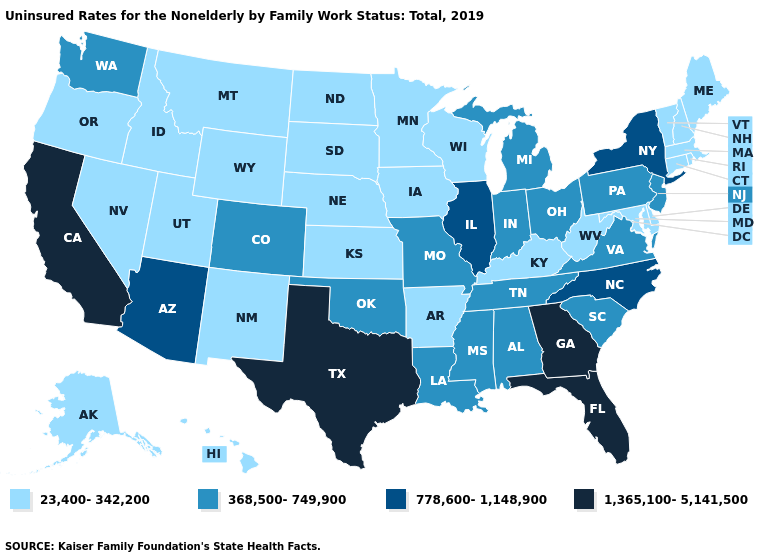What is the value of Alabama?
Short answer required. 368,500-749,900. What is the value of South Carolina?
Quick response, please. 368,500-749,900. What is the highest value in states that border Vermont?
Quick response, please. 778,600-1,148,900. What is the value of Wyoming?
Be succinct. 23,400-342,200. Which states hav the highest value in the South?
Concise answer only. Florida, Georgia, Texas. Which states have the highest value in the USA?
Quick response, please. California, Florida, Georgia, Texas. What is the highest value in states that border Wisconsin?
Concise answer only. 778,600-1,148,900. Name the states that have a value in the range 23,400-342,200?
Write a very short answer. Alaska, Arkansas, Connecticut, Delaware, Hawaii, Idaho, Iowa, Kansas, Kentucky, Maine, Maryland, Massachusetts, Minnesota, Montana, Nebraska, Nevada, New Hampshire, New Mexico, North Dakota, Oregon, Rhode Island, South Dakota, Utah, Vermont, West Virginia, Wisconsin, Wyoming. Which states have the highest value in the USA?
Quick response, please. California, Florida, Georgia, Texas. What is the lowest value in states that border Ohio?
Keep it brief. 23,400-342,200. Does New York have the highest value in the Northeast?
Be succinct. Yes. What is the value of West Virginia?
Be succinct. 23,400-342,200. What is the lowest value in the USA?
Short answer required. 23,400-342,200. Which states hav the highest value in the MidWest?
Answer briefly. Illinois. 